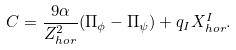<formula> <loc_0><loc_0><loc_500><loc_500>C = \frac { 9 \alpha } { Z _ { h o r } ^ { 2 } } ( \Pi _ { \phi } - \Pi _ { \psi } ) + q _ { I } X _ { h o r } ^ { I } .</formula> 